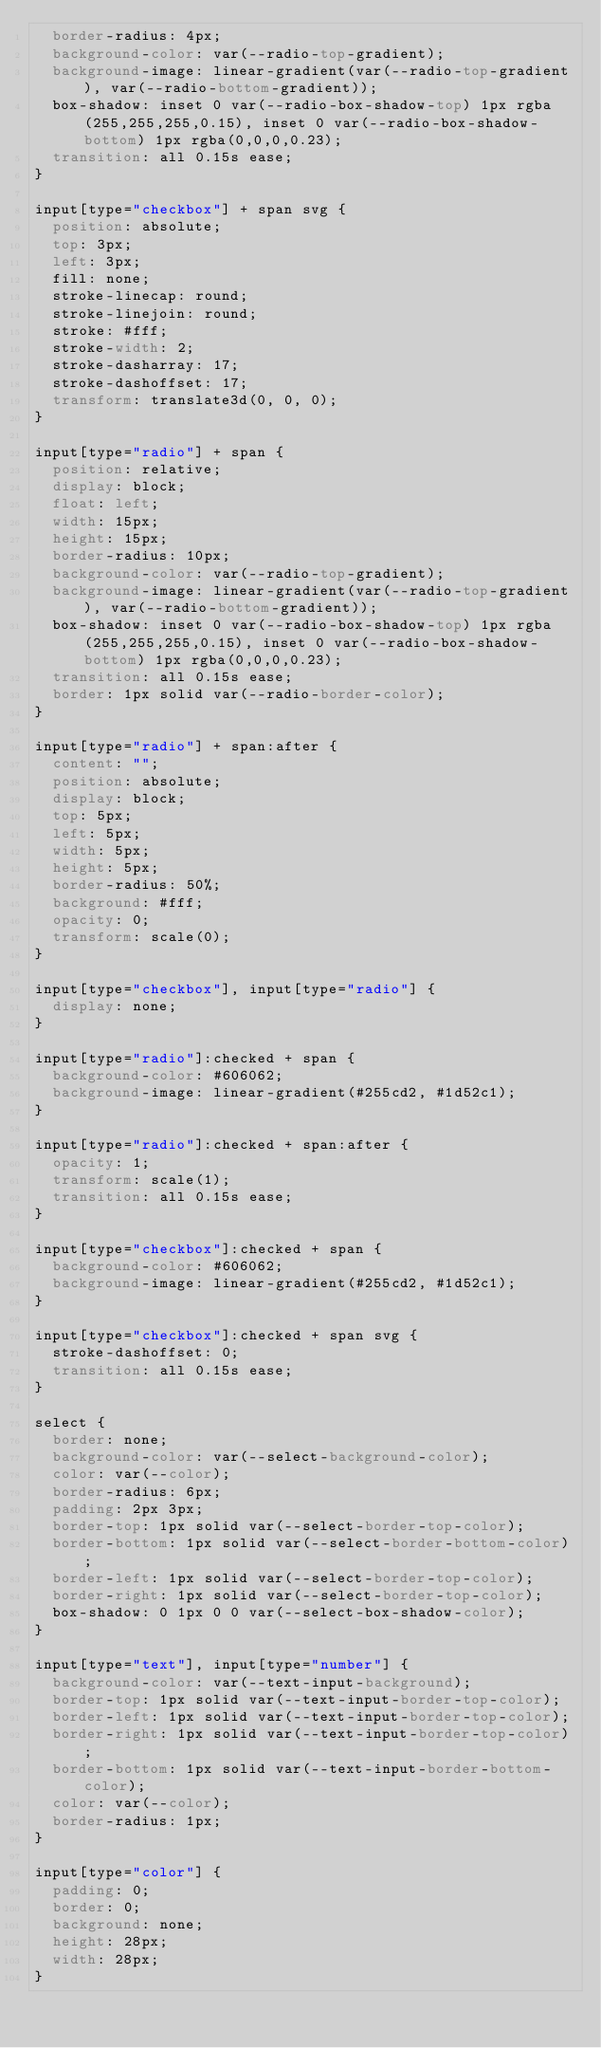Convert code to text. <code><loc_0><loc_0><loc_500><loc_500><_CSS_>  border-radius: 4px;
  background-color: var(--radio-top-gradient);
  background-image: linear-gradient(var(--radio-top-gradient), var(--radio-bottom-gradient));
  box-shadow: inset 0 var(--radio-box-shadow-top) 1px rgba(255,255,255,0.15), inset 0 var(--radio-box-shadow-bottom) 1px rgba(0,0,0,0.23);
  transition: all 0.15s ease;
}

input[type="checkbox"] + span svg {
  position: absolute;
  top: 3px;
  left: 3px;
  fill: none;
  stroke-linecap: round;
  stroke-linejoin: round;
  stroke: #fff;
  stroke-width: 2;
  stroke-dasharray: 17;
  stroke-dashoffset: 17;
  transform: translate3d(0, 0, 0);
}

input[type="radio"] + span {
  position: relative;
  display: block;
  float: left;
  width: 15px;
  height: 15px;
  border-radius: 10px;
  background-color: var(--radio-top-gradient);
  background-image: linear-gradient(var(--radio-top-gradient), var(--radio-bottom-gradient));
  box-shadow: inset 0 var(--radio-box-shadow-top) 1px rgba(255,255,255,0.15), inset 0 var(--radio-box-shadow-bottom) 1px rgba(0,0,0,0.23);
  transition: all 0.15s ease;
  border: 1px solid var(--radio-border-color);
}

input[type="radio"] + span:after {
  content: "";
  position: absolute;
  display: block;
  top: 5px;
  left: 5px;
  width: 5px;
  height: 5px;
  border-radius: 50%;
  background: #fff;
  opacity: 0;
  transform: scale(0);
}

input[type="checkbox"], input[type="radio"] {
  display: none;
}

input[type="radio"]:checked + span {
  background-color: #606062;
  background-image: linear-gradient(#255cd2, #1d52c1);
}

input[type="radio"]:checked + span:after {
  opacity: 1;
  transform: scale(1);
  transition: all 0.15s ease;
}

input[type="checkbox"]:checked + span {
  background-color: #606062;
  background-image: linear-gradient(#255cd2, #1d52c1);
}

input[type="checkbox"]:checked + span svg {
  stroke-dashoffset: 0;
  transition: all 0.15s ease;
}

select {
  border: none;
  background-color: var(--select-background-color);
  color: var(--color);
  border-radius: 6px;
  padding: 2px 3px;
  border-top: 1px solid var(--select-border-top-color);
  border-bottom: 1px solid var(--select-border-bottom-color);
  border-left: 1px solid var(--select-border-top-color);
  border-right: 1px solid var(--select-border-top-color);
  box-shadow: 0 1px 0 0 var(--select-box-shadow-color);
}

input[type="text"], input[type="number"] {
  background-color: var(--text-input-background);
  border-top: 1px solid var(--text-input-border-top-color);
  border-left: 1px solid var(--text-input-border-top-color);
  border-right: 1px solid var(--text-input-border-top-color);
  border-bottom: 1px solid var(--text-input-border-bottom-color);
  color: var(--color);
  border-radius: 1px;
}

input[type="color"] {
  padding: 0;
  border: 0;
  background: none;
  height: 28px;
  width: 28px;
}
</code> 